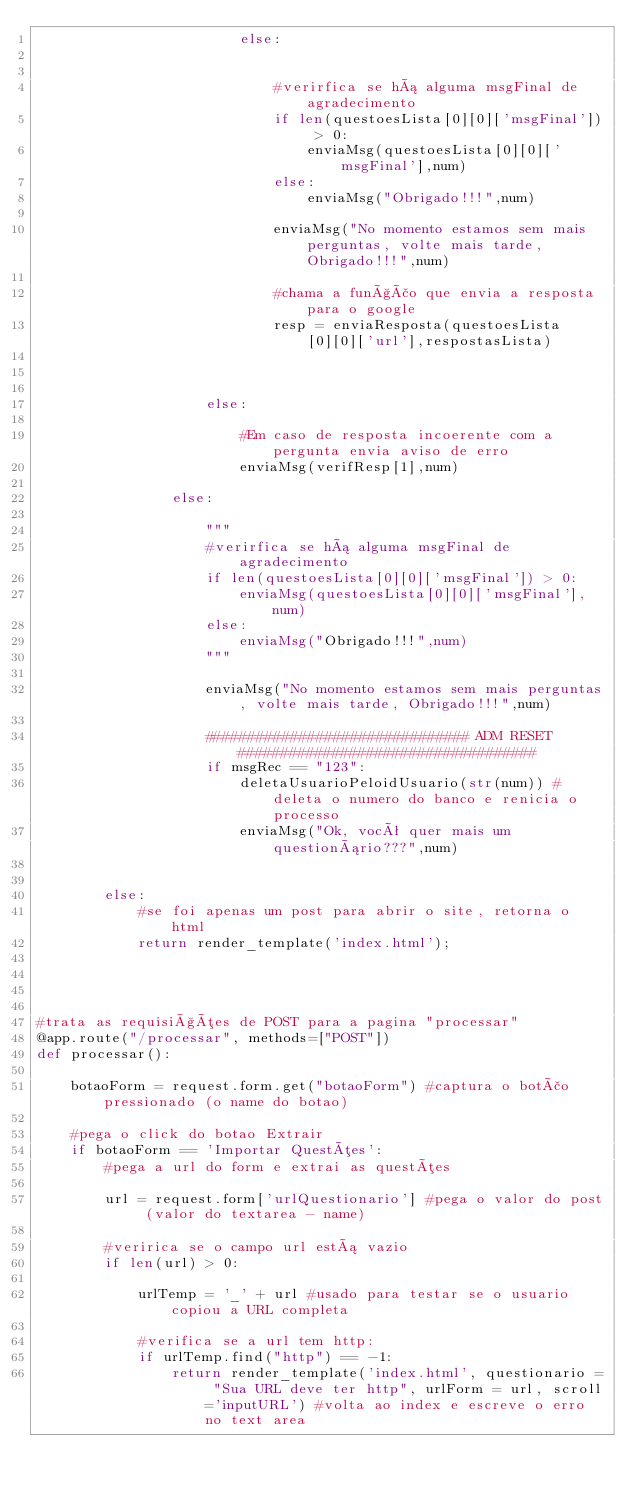<code> <loc_0><loc_0><loc_500><loc_500><_Python_>                        else:


                            #verirfica se há alguma msgFinal de agradecimento
                            if len(questoesLista[0][0]['msgFinal']) > 0:
                                enviaMsg(questoesLista[0][0]['msgFinal'],num)
                            else:
                                enviaMsg("Obrigado!!!",num)

                            enviaMsg("No momento estamos sem mais perguntas, volte mais tarde, Obrigado!!!",num)

                            #chama a função que envia a resposta para o google
                            resp = enviaResposta(questoesLista[0][0]['url'],respostasLista)



                    else:

                        #Em caso de resposta incoerente com a pergunta envia aviso de erro
                        enviaMsg(verifResp[1],num)

                else:

                    """
                    #verirfica se há alguma msgFinal de agradecimento
                    if len(questoesLista[0][0]['msgFinal']) > 0:
                        enviaMsg(questoesLista[0][0]['msgFinal'],num)
                    else:
                        enviaMsg("Obrigado!!!",num)
                    """

                    enviaMsg("No momento estamos sem mais perguntas, volte mais tarde, Obrigado!!!",num)

                    ############################### ADM RESET ###################################
                    if msgRec == "123":
                        deletaUsuarioPeloidUsuario(str(num)) #deleta o numero do banco e renicia o processo
                        enviaMsg("Ok, você quer mais um questionário???",num)


        else:
            #se foi apenas um post para abrir o site, retorna o html
            return render_template('index.html');




#trata as requisições de POST para a pagina "processar"
@app.route("/processar", methods=["POST"])
def processar():

    botaoForm = request.form.get("botaoForm") #captura o botão pressionado (o name do botao)

    #pega o click do botao Extrair
    if botaoForm == 'Importar Questões':
        #pega a url do form e extrai as questões

        url = request.form['urlQuestionario'] #pega o valor do post (valor do textarea - name)

        #veririca se o campo url está vazio
        if len(url) > 0:

            urlTemp = '_' + url #usado para testar se o usuario copiou a URL completa

            #verifica se a url tem http:
            if urlTemp.find("http") == -1:
                return render_template('index.html', questionario = "Sua URL deve ter http", urlForm = url, scroll='inputURL') #volta ao index e escreve o erro no text area

</code> 